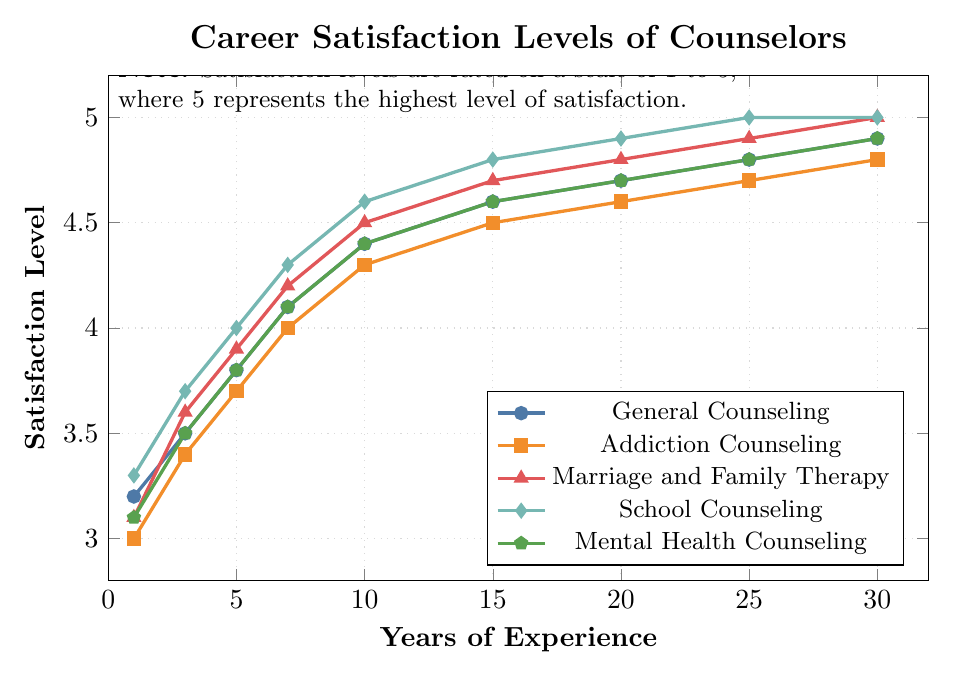What is the satisfaction level for Marriage and Family Therapy at 20 years of experience? Locate the curve for Marriage and Family Therapy, which is represented by a line with triangle markers. Identify the data point at the 20 years of experience mark, which aligns with the satisfaction level of 4.8.
Answer: 4.8 Which specialization shows the highest satisfaction level after 10 years of experience? Compare the satisfaction levels for all specializations at the 10-year mark. The highest satisfaction level is represented by the School Counseling line, which reaches 4.6.
Answer: School Counseling How does the satisfaction level of Addiction Counseling at 1 year compare to Marriage and Family Therapy at 7 years? Identify the satisfaction levels at the specified points: Addiction Counseling at 1 year is 3.0 and Marriage and Family Therapy at 7 years is 4.2. Compare by noting that 3.0 is less than 4.2.
Answer: Marriage and Family Therapy at 7 years is higher What is the average satisfaction level of General Counseling over the 30-year period? Sum the satisfaction levels for General Counseling at each point: (3.2 + 3.5 + 3.8 + 4.1 + 4.4 + 4.6 + 4.7 + 4.8 + 4.9), which equals 37. Then divide by the number of data points (9): 37 / 9 = 4.11 (rounded to two decimal places).
Answer: 4.11 What is the difference in satisfaction levels between School Counseling and General Counseling at the 25-year mark? Locate the satisfaction levels for School Counseling and General Counseling at 25 years. School Counseling is at 5.0 and General Counseling is at 4.8. The difference is 5.0 - 4.8 = 0.2.
Answer: 0.2 What trend is observed in the satisfaction levels across all specializations as years of experience increase? Observe the general direction of all lines. All specializations show an upward trend in satisfaction as the years of experience increase, indicating that career satisfaction generally increases over time for all specializations.
Answer: Increasing trend Which specialization reaches a satisfaction level of 5.0 first, and in which year? Identify the curve that first reaches the satisfaction level of 5.0. School Counseling hits the 5.0 mark at the 25-year mark, which is the first occurrence among all specializations.
Answer: School Counseling at 25 years 